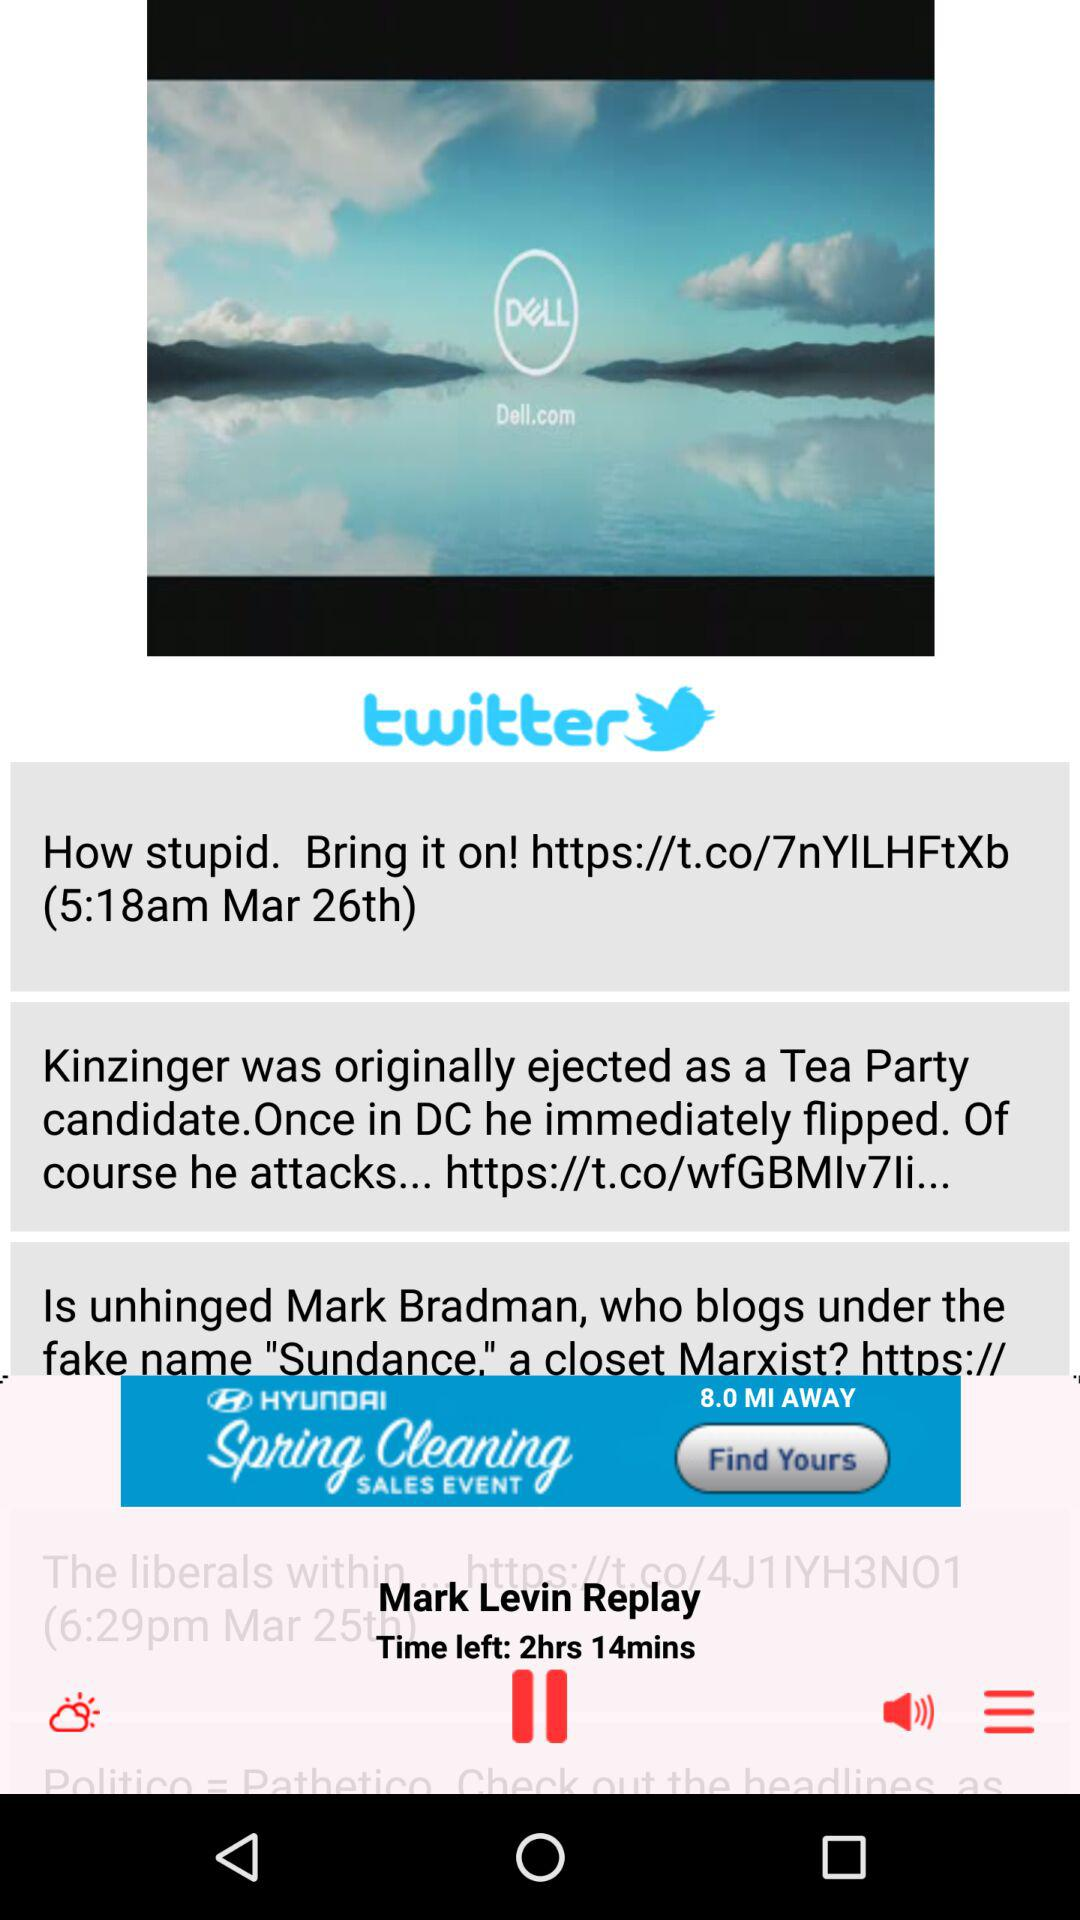How much time is left? The time left is 2 hours 14 minutes. 